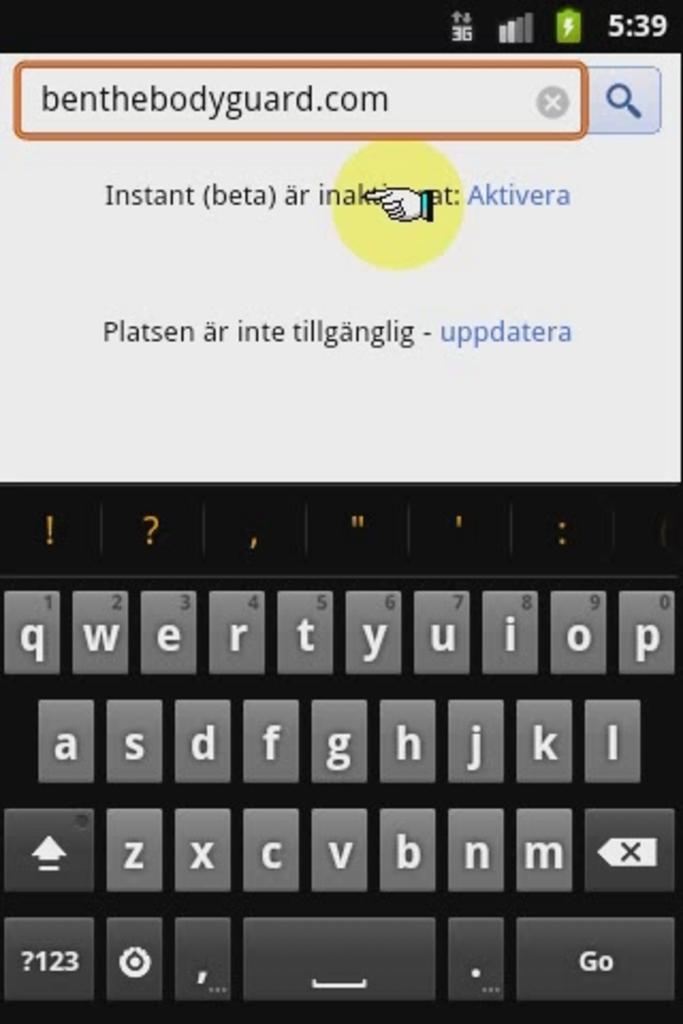What's the name of the bodyguard?
Make the answer very short. Ben. What time is displayed?
Make the answer very short. 5:39. 